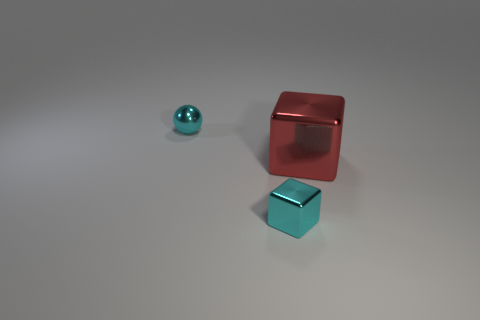Add 3 tiny cyan things. How many objects exist? 6 Subtract all cubes. How many objects are left? 1 Add 3 small gray things. How many small gray things exist? 3 Subtract 0 cyan cylinders. How many objects are left? 3 Subtract all tiny cyan balls. Subtract all big red cubes. How many objects are left? 1 Add 1 small cubes. How many small cubes are left? 2 